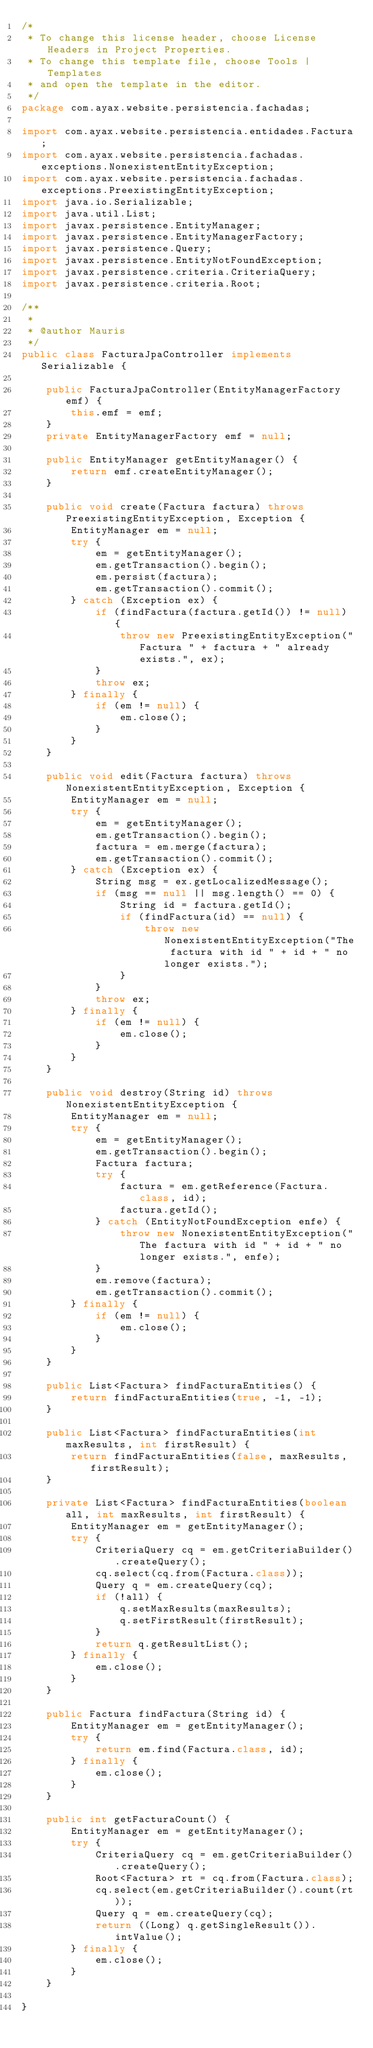Convert code to text. <code><loc_0><loc_0><loc_500><loc_500><_Java_>/*
 * To change this license header, choose License Headers in Project Properties.
 * To change this template file, choose Tools | Templates
 * and open the template in the editor.
 */
package com.ayax.website.persistencia.fachadas;

import com.ayax.website.persistencia.entidades.Factura;
import com.ayax.website.persistencia.fachadas.exceptions.NonexistentEntityException;
import com.ayax.website.persistencia.fachadas.exceptions.PreexistingEntityException;
import java.io.Serializable;
import java.util.List;
import javax.persistence.EntityManager;
import javax.persistence.EntityManagerFactory;
import javax.persistence.Query;
import javax.persistence.EntityNotFoundException;
import javax.persistence.criteria.CriteriaQuery;
import javax.persistence.criteria.Root;

/**
 *
 * @author Mauris
 */
public class FacturaJpaController implements Serializable {

    public FacturaJpaController(EntityManagerFactory emf) {
        this.emf = emf;
    }
    private EntityManagerFactory emf = null;

    public EntityManager getEntityManager() {
        return emf.createEntityManager();
    }

    public void create(Factura factura) throws PreexistingEntityException, Exception {
        EntityManager em = null;
        try {
            em = getEntityManager();
            em.getTransaction().begin();
            em.persist(factura);
            em.getTransaction().commit();
        } catch (Exception ex) {
            if (findFactura(factura.getId()) != null) {
                throw new PreexistingEntityException("Factura " + factura + " already exists.", ex);
            }
            throw ex;
        } finally {
            if (em != null) {
                em.close();
            }
        }
    }

    public void edit(Factura factura) throws NonexistentEntityException, Exception {
        EntityManager em = null;
        try {
            em = getEntityManager();
            em.getTransaction().begin();
            factura = em.merge(factura);
            em.getTransaction().commit();
        } catch (Exception ex) {
            String msg = ex.getLocalizedMessage();
            if (msg == null || msg.length() == 0) {
                String id = factura.getId();
                if (findFactura(id) == null) {
                    throw new NonexistentEntityException("The factura with id " + id + " no longer exists.");
                }
            }
            throw ex;
        } finally {
            if (em != null) {
                em.close();
            }
        }
    }

    public void destroy(String id) throws NonexistentEntityException {
        EntityManager em = null;
        try {
            em = getEntityManager();
            em.getTransaction().begin();
            Factura factura;
            try {
                factura = em.getReference(Factura.class, id);
                factura.getId();
            } catch (EntityNotFoundException enfe) {
                throw new NonexistentEntityException("The factura with id " + id + " no longer exists.", enfe);
            }
            em.remove(factura);
            em.getTransaction().commit();
        } finally {
            if (em != null) {
                em.close();
            }
        }
    }

    public List<Factura> findFacturaEntities() {
        return findFacturaEntities(true, -1, -1);
    }

    public List<Factura> findFacturaEntities(int maxResults, int firstResult) {
        return findFacturaEntities(false, maxResults, firstResult);
    }

    private List<Factura> findFacturaEntities(boolean all, int maxResults, int firstResult) {
        EntityManager em = getEntityManager();
        try {
            CriteriaQuery cq = em.getCriteriaBuilder().createQuery();
            cq.select(cq.from(Factura.class));
            Query q = em.createQuery(cq);
            if (!all) {
                q.setMaxResults(maxResults);
                q.setFirstResult(firstResult);
            }
            return q.getResultList();
        } finally {
            em.close();
        }
    }

    public Factura findFactura(String id) {
        EntityManager em = getEntityManager();
        try {
            return em.find(Factura.class, id);
        } finally {
            em.close();
        }
    }

    public int getFacturaCount() {
        EntityManager em = getEntityManager();
        try {
            CriteriaQuery cq = em.getCriteriaBuilder().createQuery();
            Root<Factura> rt = cq.from(Factura.class);
            cq.select(em.getCriteriaBuilder().count(rt));
            Query q = em.createQuery(cq);
            return ((Long) q.getSingleResult()).intValue();
        } finally {
            em.close();
        }
    }
    
}
</code> 